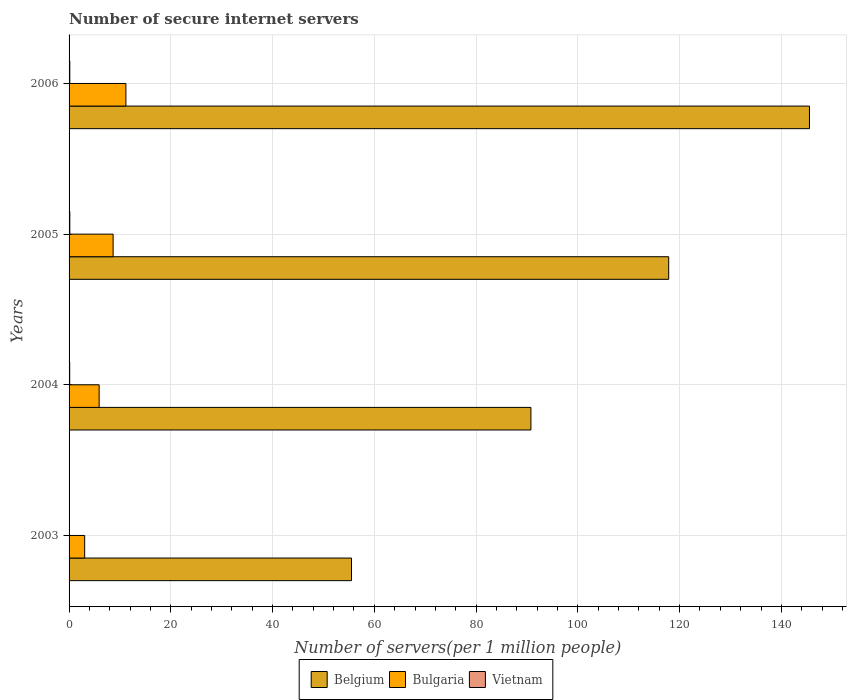How many groups of bars are there?
Your response must be concise. 4. Are the number of bars per tick equal to the number of legend labels?
Your answer should be compact. Yes. How many bars are there on the 2nd tick from the bottom?
Provide a succinct answer. 3. What is the number of secure internet servers in Belgium in 2004?
Give a very brief answer. 90.78. Across all years, what is the maximum number of secure internet servers in Vietnam?
Offer a terse response. 0.15. Across all years, what is the minimum number of secure internet servers in Belgium?
Give a very brief answer. 55.51. In which year was the number of secure internet servers in Vietnam maximum?
Give a very brief answer. 2005. In which year was the number of secure internet servers in Belgium minimum?
Provide a succinct answer. 2003. What is the total number of secure internet servers in Vietnam in the graph?
Your answer should be very brief. 0.45. What is the difference between the number of secure internet servers in Vietnam in 2005 and that in 2006?
Provide a succinct answer. 0. What is the difference between the number of secure internet servers in Bulgaria in 2006 and the number of secure internet servers in Vietnam in 2003?
Offer a terse response. 11.13. What is the average number of secure internet servers in Bulgaria per year?
Keep it short and to the point. 7.2. In the year 2005, what is the difference between the number of secure internet servers in Belgium and number of secure internet servers in Bulgaria?
Provide a succinct answer. 109.2. What is the ratio of the number of secure internet servers in Vietnam in 2004 to that in 2006?
Your answer should be compact. 0.85. Is the number of secure internet servers in Bulgaria in 2003 less than that in 2005?
Your answer should be compact. Yes. Is the difference between the number of secure internet servers in Belgium in 2003 and 2005 greater than the difference between the number of secure internet servers in Bulgaria in 2003 and 2005?
Offer a very short reply. No. What is the difference between the highest and the second highest number of secure internet servers in Belgium?
Ensure brevity in your answer.  27.67. What is the difference between the highest and the lowest number of secure internet servers in Belgium?
Make the answer very short. 90.01. In how many years, is the number of secure internet servers in Belgium greater than the average number of secure internet servers in Belgium taken over all years?
Keep it short and to the point. 2. Is the sum of the number of secure internet servers in Vietnam in 2004 and 2005 greater than the maximum number of secure internet servers in Bulgaria across all years?
Provide a succinct answer. No. What does the 2nd bar from the top in 2006 represents?
Provide a short and direct response. Bulgaria. What does the 1st bar from the bottom in 2006 represents?
Your answer should be very brief. Belgium. How many bars are there?
Ensure brevity in your answer.  12. How many years are there in the graph?
Ensure brevity in your answer.  4. Does the graph contain grids?
Give a very brief answer. Yes. Where does the legend appear in the graph?
Offer a very short reply. Bottom center. How are the legend labels stacked?
Provide a succinct answer. Horizontal. What is the title of the graph?
Provide a short and direct response. Number of secure internet servers. Does "Euro area" appear as one of the legend labels in the graph?
Keep it short and to the point. No. What is the label or title of the X-axis?
Give a very brief answer. Number of servers(per 1 million people). What is the Number of servers(per 1 million people) in Belgium in 2003?
Make the answer very short. 55.51. What is the Number of servers(per 1 million people) of Bulgaria in 2003?
Offer a very short reply. 3.07. What is the Number of servers(per 1 million people) of Vietnam in 2003?
Ensure brevity in your answer.  0.04. What is the Number of servers(per 1 million people) in Belgium in 2004?
Provide a succinct answer. 90.78. What is the Number of servers(per 1 million people) of Bulgaria in 2004?
Offer a terse response. 5.91. What is the Number of servers(per 1 million people) of Vietnam in 2004?
Give a very brief answer. 0.12. What is the Number of servers(per 1 million people) of Belgium in 2005?
Offer a very short reply. 117.86. What is the Number of servers(per 1 million people) in Bulgaria in 2005?
Make the answer very short. 8.66. What is the Number of servers(per 1 million people) of Vietnam in 2005?
Your answer should be compact. 0.15. What is the Number of servers(per 1 million people) of Belgium in 2006?
Your answer should be compact. 145.53. What is the Number of servers(per 1 million people) in Bulgaria in 2006?
Provide a short and direct response. 11.17. What is the Number of servers(per 1 million people) in Vietnam in 2006?
Your response must be concise. 0.14. Across all years, what is the maximum Number of servers(per 1 million people) of Belgium?
Your response must be concise. 145.53. Across all years, what is the maximum Number of servers(per 1 million people) in Bulgaria?
Offer a terse response. 11.17. Across all years, what is the maximum Number of servers(per 1 million people) in Vietnam?
Offer a very short reply. 0.15. Across all years, what is the minimum Number of servers(per 1 million people) of Belgium?
Offer a terse response. 55.51. Across all years, what is the minimum Number of servers(per 1 million people) of Bulgaria?
Your answer should be compact. 3.07. Across all years, what is the minimum Number of servers(per 1 million people) of Vietnam?
Make the answer very short. 0.04. What is the total Number of servers(per 1 million people) in Belgium in the graph?
Keep it short and to the point. 409.67. What is the total Number of servers(per 1 million people) of Bulgaria in the graph?
Keep it short and to the point. 28.81. What is the total Number of servers(per 1 million people) in Vietnam in the graph?
Make the answer very short. 0.45. What is the difference between the Number of servers(per 1 million people) in Belgium in 2003 and that in 2004?
Your answer should be very brief. -35.27. What is the difference between the Number of servers(per 1 million people) of Bulgaria in 2003 and that in 2004?
Keep it short and to the point. -2.84. What is the difference between the Number of servers(per 1 million people) of Vietnam in 2003 and that in 2004?
Offer a terse response. -0.09. What is the difference between the Number of servers(per 1 million people) in Belgium in 2003 and that in 2005?
Make the answer very short. -62.35. What is the difference between the Number of servers(per 1 million people) in Bulgaria in 2003 and that in 2005?
Provide a short and direct response. -5.59. What is the difference between the Number of servers(per 1 million people) of Vietnam in 2003 and that in 2005?
Keep it short and to the point. -0.11. What is the difference between the Number of servers(per 1 million people) in Belgium in 2003 and that in 2006?
Ensure brevity in your answer.  -90.01. What is the difference between the Number of servers(per 1 million people) in Bulgaria in 2003 and that in 2006?
Give a very brief answer. -8.1. What is the difference between the Number of servers(per 1 million people) in Vietnam in 2003 and that in 2006?
Your answer should be very brief. -0.11. What is the difference between the Number of servers(per 1 million people) in Belgium in 2004 and that in 2005?
Provide a short and direct response. -27.08. What is the difference between the Number of servers(per 1 million people) of Bulgaria in 2004 and that in 2005?
Provide a short and direct response. -2.74. What is the difference between the Number of servers(per 1 million people) in Vietnam in 2004 and that in 2005?
Offer a very short reply. -0.02. What is the difference between the Number of servers(per 1 million people) in Belgium in 2004 and that in 2006?
Ensure brevity in your answer.  -54.75. What is the difference between the Number of servers(per 1 million people) in Bulgaria in 2004 and that in 2006?
Offer a terse response. -5.26. What is the difference between the Number of servers(per 1 million people) of Vietnam in 2004 and that in 2006?
Offer a terse response. -0.02. What is the difference between the Number of servers(per 1 million people) of Belgium in 2005 and that in 2006?
Your answer should be very brief. -27.67. What is the difference between the Number of servers(per 1 million people) in Bulgaria in 2005 and that in 2006?
Provide a short and direct response. -2.51. What is the difference between the Number of servers(per 1 million people) of Vietnam in 2005 and that in 2006?
Ensure brevity in your answer.  0. What is the difference between the Number of servers(per 1 million people) of Belgium in 2003 and the Number of servers(per 1 million people) of Bulgaria in 2004?
Your answer should be compact. 49.6. What is the difference between the Number of servers(per 1 million people) of Belgium in 2003 and the Number of servers(per 1 million people) of Vietnam in 2004?
Offer a very short reply. 55.39. What is the difference between the Number of servers(per 1 million people) in Bulgaria in 2003 and the Number of servers(per 1 million people) in Vietnam in 2004?
Your answer should be very brief. 2.94. What is the difference between the Number of servers(per 1 million people) of Belgium in 2003 and the Number of servers(per 1 million people) of Bulgaria in 2005?
Give a very brief answer. 46.86. What is the difference between the Number of servers(per 1 million people) in Belgium in 2003 and the Number of servers(per 1 million people) in Vietnam in 2005?
Your answer should be compact. 55.37. What is the difference between the Number of servers(per 1 million people) in Bulgaria in 2003 and the Number of servers(per 1 million people) in Vietnam in 2005?
Offer a terse response. 2.92. What is the difference between the Number of servers(per 1 million people) of Belgium in 2003 and the Number of servers(per 1 million people) of Bulgaria in 2006?
Provide a short and direct response. 44.34. What is the difference between the Number of servers(per 1 million people) of Belgium in 2003 and the Number of servers(per 1 million people) of Vietnam in 2006?
Your response must be concise. 55.37. What is the difference between the Number of servers(per 1 million people) in Bulgaria in 2003 and the Number of servers(per 1 million people) in Vietnam in 2006?
Offer a very short reply. 2.92. What is the difference between the Number of servers(per 1 million people) in Belgium in 2004 and the Number of servers(per 1 million people) in Bulgaria in 2005?
Provide a short and direct response. 82.12. What is the difference between the Number of servers(per 1 million people) in Belgium in 2004 and the Number of servers(per 1 million people) in Vietnam in 2005?
Offer a terse response. 90.63. What is the difference between the Number of servers(per 1 million people) in Bulgaria in 2004 and the Number of servers(per 1 million people) in Vietnam in 2005?
Ensure brevity in your answer.  5.77. What is the difference between the Number of servers(per 1 million people) in Belgium in 2004 and the Number of servers(per 1 million people) in Bulgaria in 2006?
Provide a succinct answer. 79.61. What is the difference between the Number of servers(per 1 million people) of Belgium in 2004 and the Number of servers(per 1 million people) of Vietnam in 2006?
Provide a succinct answer. 90.63. What is the difference between the Number of servers(per 1 million people) in Bulgaria in 2004 and the Number of servers(per 1 million people) in Vietnam in 2006?
Your response must be concise. 5.77. What is the difference between the Number of servers(per 1 million people) in Belgium in 2005 and the Number of servers(per 1 million people) in Bulgaria in 2006?
Make the answer very short. 106.69. What is the difference between the Number of servers(per 1 million people) of Belgium in 2005 and the Number of servers(per 1 million people) of Vietnam in 2006?
Provide a succinct answer. 117.72. What is the difference between the Number of servers(per 1 million people) in Bulgaria in 2005 and the Number of servers(per 1 million people) in Vietnam in 2006?
Offer a terse response. 8.51. What is the average Number of servers(per 1 million people) in Belgium per year?
Your answer should be compact. 102.42. What is the average Number of servers(per 1 million people) of Bulgaria per year?
Offer a very short reply. 7.2. What is the average Number of servers(per 1 million people) in Vietnam per year?
Your answer should be very brief. 0.11. In the year 2003, what is the difference between the Number of servers(per 1 million people) in Belgium and Number of servers(per 1 million people) in Bulgaria?
Offer a very short reply. 52.44. In the year 2003, what is the difference between the Number of servers(per 1 million people) of Belgium and Number of servers(per 1 million people) of Vietnam?
Your answer should be compact. 55.47. In the year 2003, what is the difference between the Number of servers(per 1 million people) in Bulgaria and Number of servers(per 1 million people) in Vietnam?
Make the answer very short. 3.03. In the year 2004, what is the difference between the Number of servers(per 1 million people) of Belgium and Number of servers(per 1 million people) of Bulgaria?
Your answer should be very brief. 84.87. In the year 2004, what is the difference between the Number of servers(per 1 million people) in Belgium and Number of servers(per 1 million people) in Vietnam?
Provide a succinct answer. 90.65. In the year 2004, what is the difference between the Number of servers(per 1 million people) of Bulgaria and Number of servers(per 1 million people) of Vietnam?
Provide a succinct answer. 5.79. In the year 2005, what is the difference between the Number of servers(per 1 million people) of Belgium and Number of servers(per 1 million people) of Bulgaria?
Give a very brief answer. 109.2. In the year 2005, what is the difference between the Number of servers(per 1 million people) of Belgium and Number of servers(per 1 million people) of Vietnam?
Offer a terse response. 117.71. In the year 2005, what is the difference between the Number of servers(per 1 million people) in Bulgaria and Number of servers(per 1 million people) in Vietnam?
Your answer should be very brief. 8.51. In the year 2006, what is the difference between the Number of servers(per 1 million people) of Belgium and Number of servers(per 1 million people) of Bulgaria?
Provide a short and direct response. 134.36. In the year 2006, what is the difference between the Number of servers(per 1 million people) of Belgium and Number of servers(per 1 million people) of Vietnam?
Keep it short and to the point. 145.38. In the year 2006, what is the difference between the Number of servers(per 1 million people) of Bulgaria and Number of servers(per 1 million people) of Vietnam?
Ensure brevity in your answer.  11.03. What is the ratio of the Number of servers(per 1 million people) of Belgium in 2003 to that in 2004?
Your answer should be compact. 0.61. What is the ratio of the Number of servers(per 1 million people) of Bulgaria in 2003 to that in 2004?
Offer a terse response. 0.52. What is the ratio of the Number of servers(per 1 million people) of Vietnam in 2003 to that in 2004?
Make the answer very short. 0.3. What is the ratio of the Number of servers(per 1 million people) in Belgium in 2003 to that in 2005?
Offer a terse response. 0.47. What is the ratio of the Number of servers(per 1 million people) in Bulgaria in 2003 to that in 2005?
Keep it short and to the point. 0.35. What is the ratio of the Number of servers(per 1 million people) in Vietnam in 2003 to that in 2005?
Your answer should be compact. 0.26. What is the ratio of the Number of servers(per 1 million people) of Belgium in 2003 to that in 2006?
Your answer should be very brief. 0.38. What is the ratio of the Number of servers(per 1 million people) in Bulgaria in 2003 to that in 2006?
Your answer should be very brief. 0.27. What is the ratio of the Number of servers(per 1 million people) of Vietnam in 2003 to that in 2006?
Provide a short and direct response. 0.26. What is the ratio of the Number of servers(per 1 million people) of Belgium in 2004 to that in 2005?
Provide a succinct answer. 0.77. What is the ratio of the Number of servers(per 1 million people) of Bulgaria in 2004 to that in 2005?
Ensure brevity in your answer.  0.68. What is the ratio of the Number of servers(per 1 million people) of Vietnam in 2004 to that in 2005?
Ensure brevity in your answer.  0.84. What is the ratio of the Number of servers(per 1 million people) of Belgium in 2004 to that in 2006?
Provide a short and direct response. 0.62. What is the ratio of the Number of servers(per 1 million people) of Bulgaria in 2004 to that in 2006?
Provide a succinct answer. 0.53. What is the ratio of the Number of servers(per 1 million people) of Vietnam in 2004 to that in 2006?
Offer a very short reply. 0.85. What is the ratio of the Number of servers(per 1 million people) of Belgium in 2005 to that in 2006?
Provide a short and direct response. 0.81. What is the ratio of the Number of servers(per 1 million people) in Bulgaria in 2005 to that in 2006?
Make the answer very short. 0.78. What is the ratio of the Number of servers(per 1 million people) in Vietnam in 2005 to that in 2006?
Your answer should be very brief. 1.01. What is the difference between the highest and the second highest Number of servers(per 1 million people) of Belgium?
Provide a succinct answer. 27.67. What is the difference between the highest and the second highest Number of servers(per 1 million people) of Bulgaria?
Keep it short and to the point. 2.51. What is the difference between the highest and the second highest Number of servers(per 1 million people) of Vietnam?
Your response must be concise. 0. What is the difference between the highest and the lowest Number of servers(per 1 million people) in Belgium?
Offer a terse response. 90.01. What is the difference between the highest and the lowest Number of servers(per 1 million people) in Bulgaria?
Keep it short and to the point. 8.1. What is the difference between the highest and the lowest Number of servers(per 1 million people) of Vietnam?
Offer a very short reply. 0.11. 